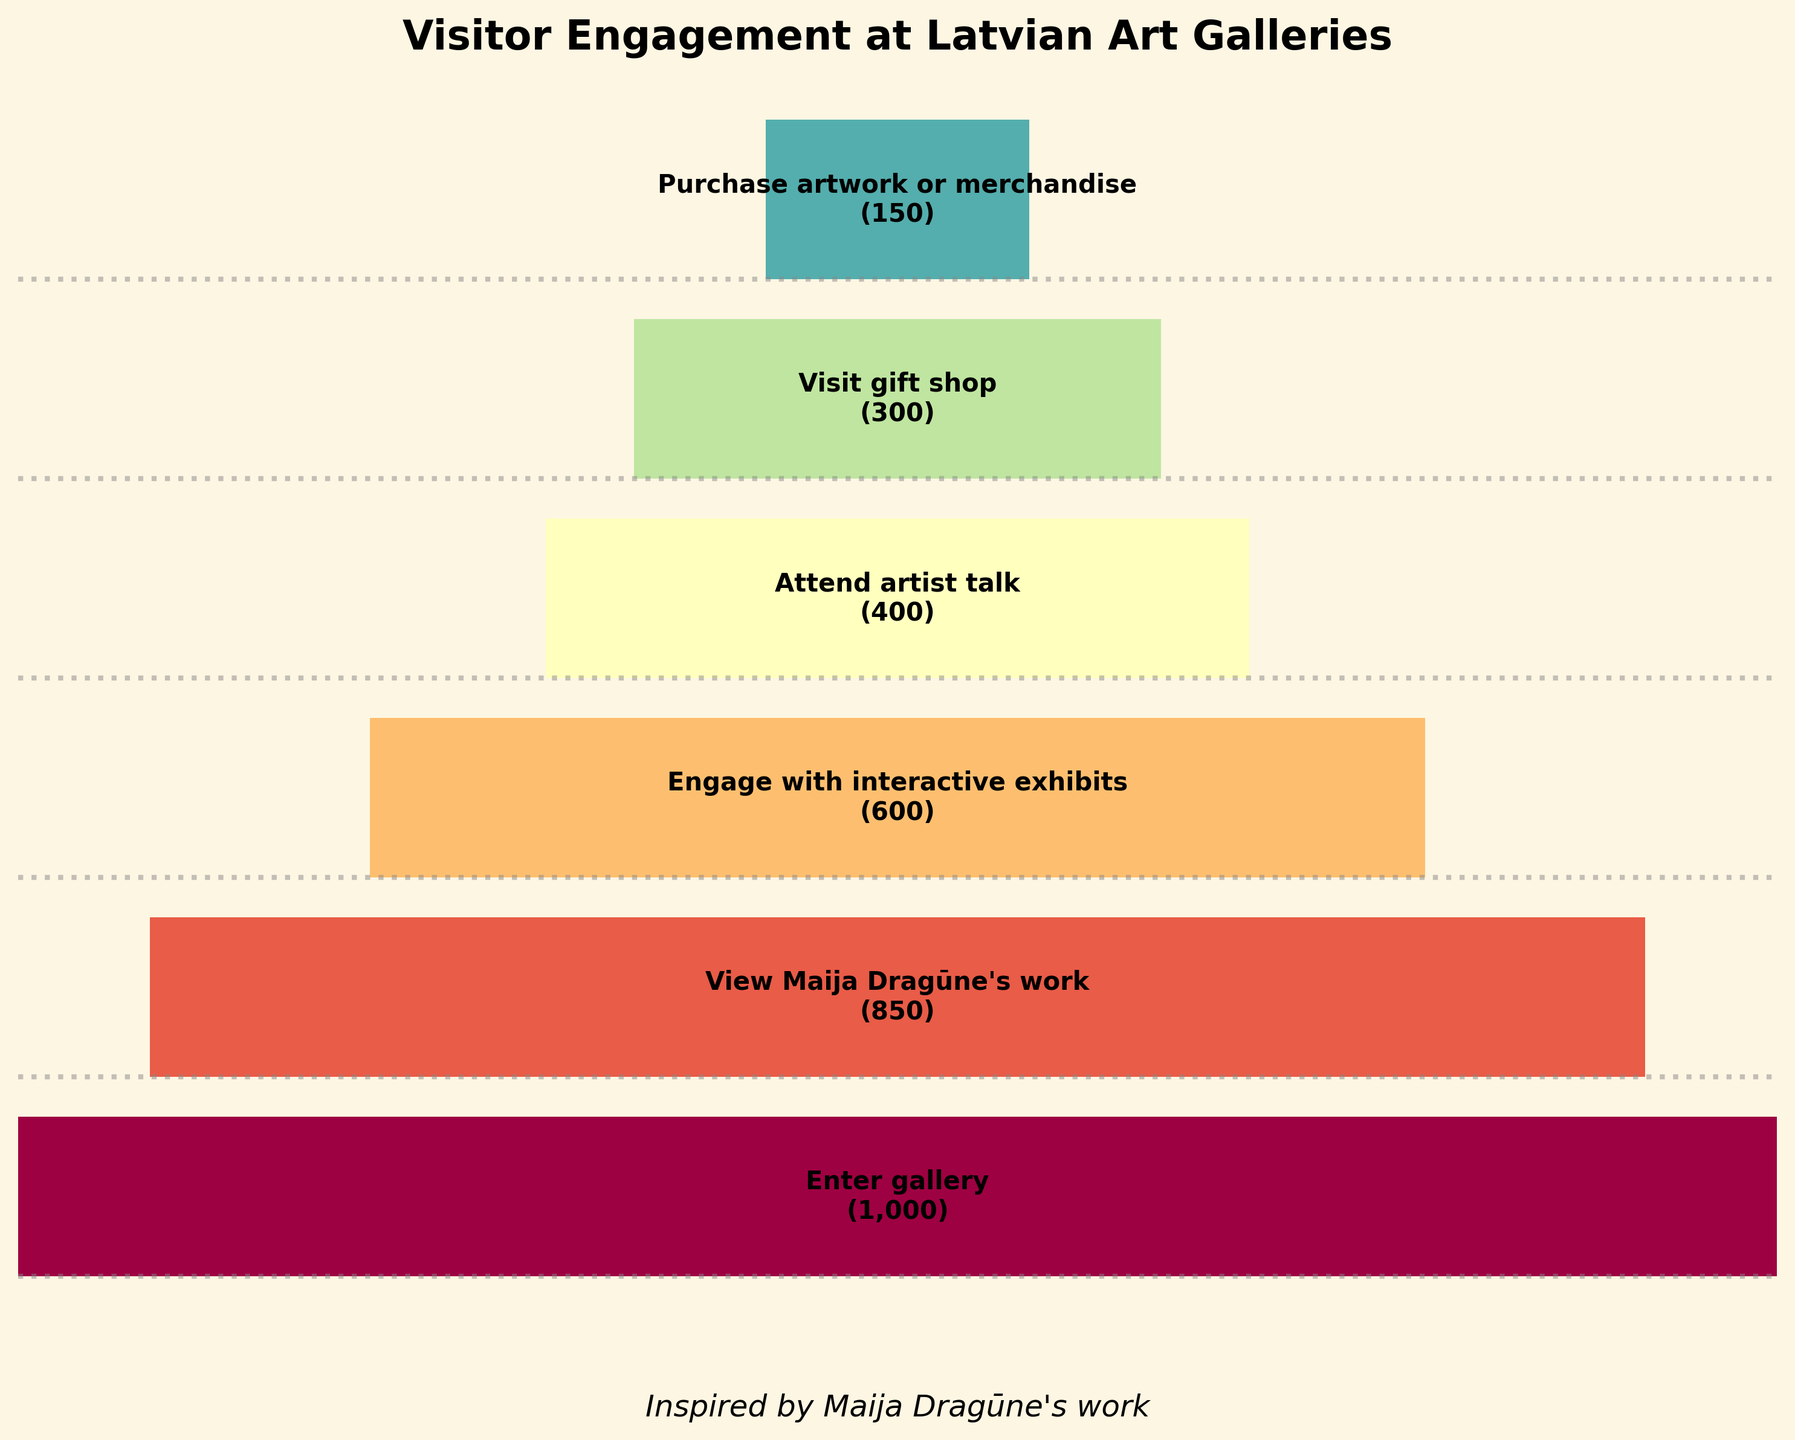What is the title of the chart? The title is prominently displayed at the top of the chart in bold. It reads "Visitor Engagement at Latvian Art Galleries."
Answer: "Visitor Engagement at Latvian Art Galleries" How many stages are shown in the funnel chart? The chart shows a sequence of bars corresponding to each stage. By counting these bars, we find there are six stages.
Answer: Six How many visitors attended an artist talk compared to those who entered the gallery? The chart indicates that 400 visitors attended an artist talk out of 1000 who entered the gallery.
Answer: 400 attended an artist talk while 1000 entered the gallery What percentage of visitors who entered the gallery ended up purchasing artwork or merchandise? 150 visitors purchased artwork or merchandise out of 1000 who entered the gallery. The percentage is calculated by (150/1000) * 100 = 15%.
Answer: 15% Which stage experienced the largest drop in visitor numbers? By comparing the differences between each stage, the drop from "Engage with interactive exhibits" (600 visitors) to "Attend artist talk" (400 visitors) is the largest, a drop of 200 visitors.
Answer: The drop between "Engage with interactive exhibits" and "Attend artist talk" In the stage "View Maija Dragūne's work," what percentage of initial visitors decided to engage with the interactive exhibits? From "View Maija Dragūne's work" (850 visitors), 600 engaged with the interactive exhibits. The percentage is calculated as (600/850) * 100 ≈ 70.59%.
Answer: Approximately 70.59% Is there a decorative element mentioned in the plot, and what form does it take? The plot includes a decorative element in the form of dotted lines that run horizontally across the funnel chart.
Answer: Dotted lines How many visitors visited the gift shop, and how does this compare to those who engaged with interactive exhibits? 300 visitors visited the gift shop compared to 600 who engaged with interactive exhibits. This is half of the number who engaged with the exhibits.
Answer: 300 visitors visited the gift shop, half of those who engaged with interactive exhibits What is the funnel stage with the least visitor engagement, and what is the visitor count at that stage? The final stage "Purchase artwork or merchandise" has the least engagement with 150 visitors.
Answer: "Purchase artwork or merchandise" with 150 visitors What can be inferred about the visitor engagement levels inspired by Maija Dragūne's work at the gallery? After viewing her work, the visitor count drops from 850 to subsequent stages but a significant portion continues to engage with the gallery's offerings, indicating strong initial interest.
Answer: Strong initial interest, followed by declining engagement 